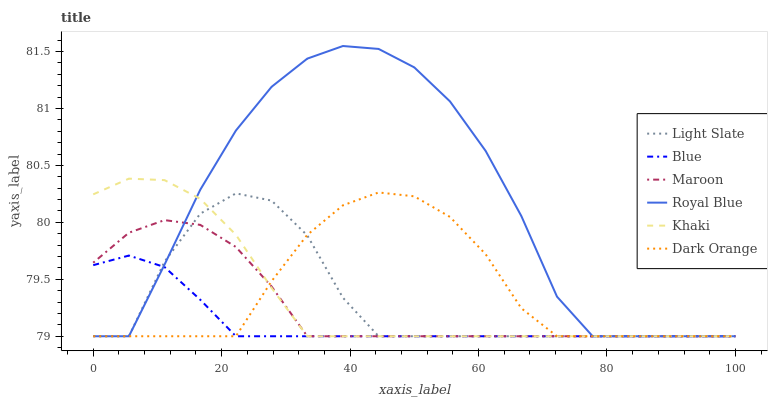Does Blue have the minimum area under the curve?
Answer yes or no. Yes. Does Royal Blue have the maximum area under the curve?
Answer yes or no. Yes. Does Dark Orange have the minimum area under the curve?
Answer yes or no. No. Does Dark Orange have the maximum area under the curve?
Answer yes or no. No. Is Blue the smoothest?
Answer yes or no. Yes. Is Royal Blue the roughest?
Answer yes or no. Yes. Is Dark Orange the smoothest?
Answer yes or no. No. Is Dark Orange the roughest?
Answer yes or no. No. Does Blue have the lowest value?
Answer yes or no. Yes. Does Royal Blue have the highest value?
Answer yes or no. Yes. Does Dark Orange have the highest value?
Answer yes or no. No. Does Dark Orange intersect Maroon?
Answer yes or no. Yes. Is Dark Orange less than Maroon?
Answer yes or no. No. Is Dark Orange greater than Maroon?
Answer yes or no. No. 